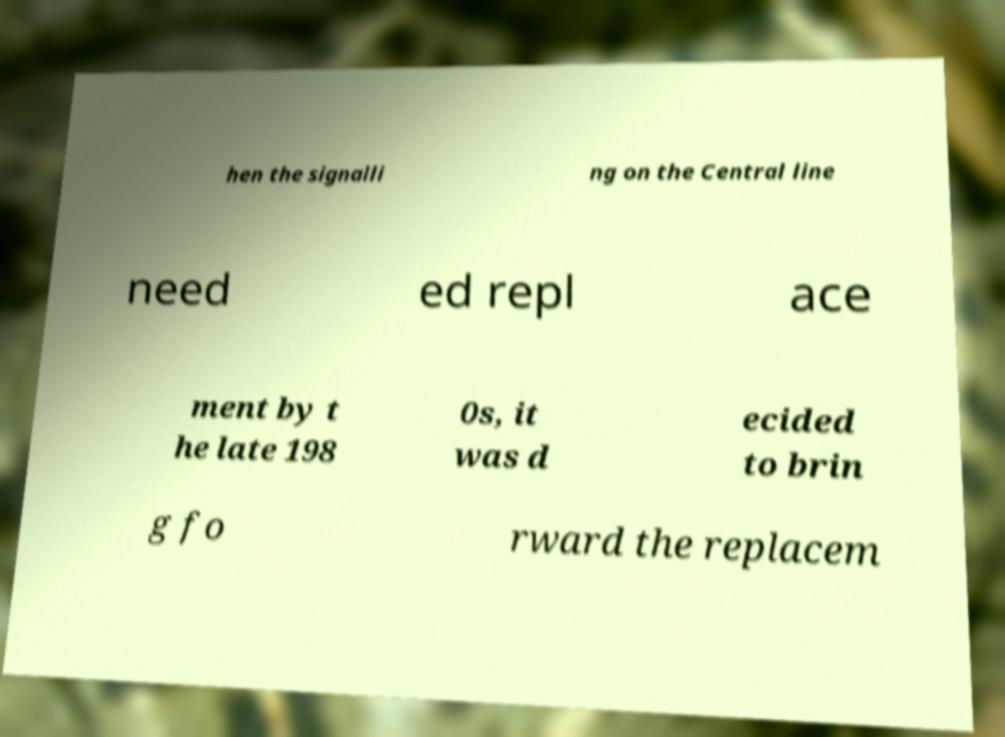What messages or text are displayed in this image? I need them in a readable, typed format. hen the signalli ng on the Central line need ed repl ace ment by t he late 198 0s, it was d ecided to brin g fo rward the replacem 